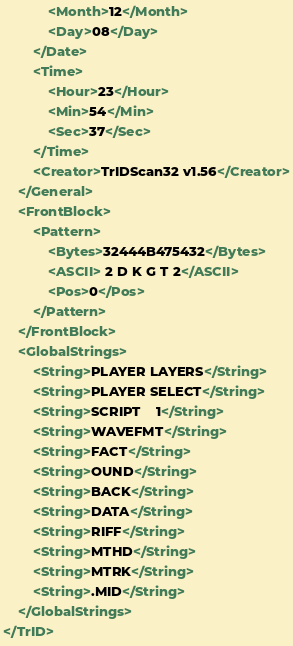Convert code to text. <code><loc_0><loc_0><loc_500><loc_500><_XML_>			<Month>12</Month>
			<Day>08</Day>
		</Date>
		<Time>
			<Hour>23</Hour>
			<Min>54</Min>
			<Sec>37</Sec>
		</Time>
		<Creator>TrIDScan32 v1.56</Creator>
	</General>
	<FrontBlock>
		<Pattern>
			<Bytes>32444B475432</Bytes>
			<ASCII> 2 D K G T 2</ASCII>
			<Pos>0</Pos>
		</Pattern>
	</FrontBlock>
	<GlobalStrings>
		<String>PLAYER LAYERS</String>
		<String>PLAYER SELECT</String>
		<String>SCRIPT    1</String>
		<String>WAVEFMT</String>
		<String>FACT</String>
		<String>OUND</String>
		<String>BACK</String>
		<String>DATA</String>
		<String>RIFF</String>
		<String>MTHD</String>
		<String>MTRK</String>
		<String>.MID</String>
	</GlobalStrings>
</TrID>
</code> 